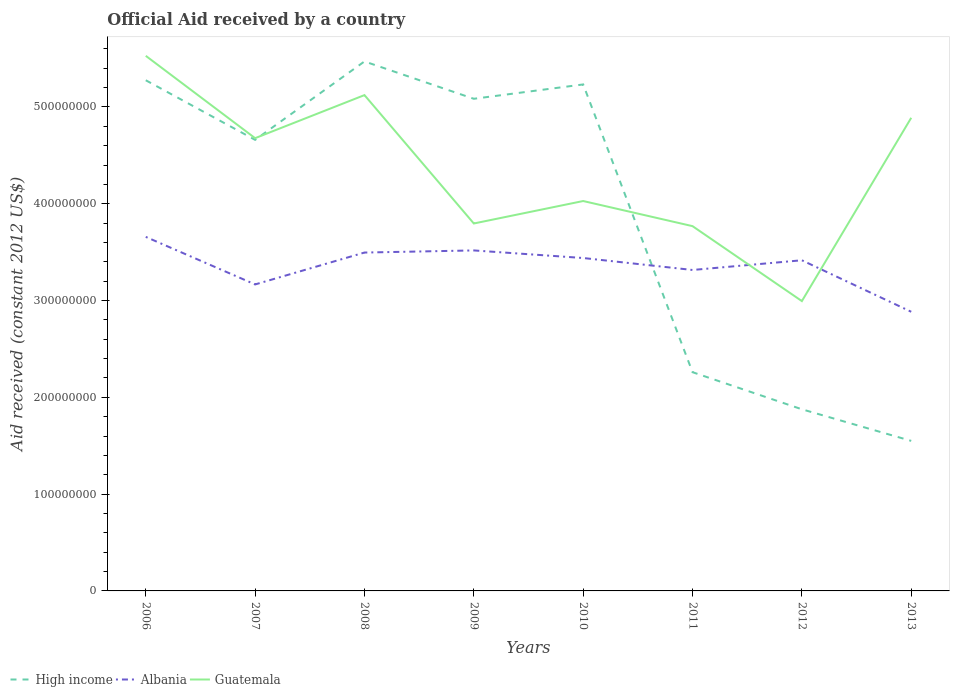How many different coloured lines are there?
Provide a short and direct response. 3. Does the line corresponding to Guatemala intersect with the line corresponding to High income?
Offer a terse response. Yes. Is the number of lines equal to the number of legend labels?
Keep it short and to the point. Yes. Across all years, what is the maximum net official aid received in Albania?
Your answer should be compact. 2.88e+08. In which year was the net official aid received in Albania maximum?
Give a very brief answer. 2013. What is the total net official aid received in High income in the graph?
Keep it short and to the point. 3.02e+08. What is the difference between the highest and the second highest net official aid received in Guatemala?
Provide a succinct answer. 2.53e+08. What is the difference between the highest and the lowest net official aid received in High income?
Your answer should be very brief. 5. How many lines are there?
Keep it short and to the point. 3. How many years are there in the graph?
Offer a very short reply. 8. Does the graph contain any zero values?
Your answer should be very brief. No. Does the graph contain grids?
Give a very brief answer. No. Where does the legend appear in the graph?
Ensure brevity in your answer.  Bottom left. How many legend labels are there?
Offer a very short reply. 3. How are the legend labels stacked?
Your response must be concise. Horizontal. What is the title of the graph?
Your response must be concise. Official Aid received by a country. What is the label or title of the Y-axis?
Offer a very short reply. Aid received (constant 2012 US$). What is the Aid received (constant 2012 US$) in High income in 2006?
Your response must be concise. 5.28e+08. What is the Aid received (constant 2012 US$) of Albania in 2006?
Your answer should be very brief. 3.66e+08. What is the Aid received (constant 2012 US$) of Guatemala in 2006?
Offer a terse response. 5.53e+08. What is the Aid received (constant 2012 US$) in High income in 2007?
Ensure brevity in your answer.  4.66e+08. What is the Aid received (constant 2012 US$) of Albania in 2007?
Give a very brief answer. 3.17e+08. What is the Aid received (constant 2012 US$) of Guatemala in 2007?
Your answer should be very brief. 4.68e+08. What is the Aid received (constant 2012 US$) of High income in 2008?
Provide a succinct answer. 5.47e+08. What is the Aid received (constant 2012 US$) of Albania in 2008?
Provide a short and direct response. 3.50e+08. What is the Aid received (constant 2012 US$) of Guatemala in 2008?
Offer a very short reply. 5.12e+08. What is the Aid received (constant 2012 US$) of High income in 2009?
Offer a very short reply. 5.08e+08. What is the Aid received (constant 2012 US$) in Albania in 2009?
Make the answer very short. 3.52e+08. What is the Aid received (constant 2012 US$) of Guatemala in 2009?
Offer a very short reply. 3.80e+08. What is the Aid received (constant 2012 US$) of High income in 2010?
Ensure brevity in your answer.  5.23e+08. What is the Aid received (constant 2012 US$) of Albania in 2010?
Provide a short and direct response. 3.44e+08. What is the Aid received (constant 2012 US$) in Guatemala in 2010?
Offer a terse response. 4.03e+08. What is the Aid received (constant 2012 US$) in High income in 2011?
Keep it short and to the point. 2.26e+08. What is the Aid received (constant 2012 US$) of Albania in 2011?
Offer a terse response. 3.32e+08. What is the Aid received (constant 2012 US$) in Guatemala in 2011?
Make the answer very short. 3.77e+08. What is the Aid received (constant 2012 US$) of High income in 2012?
Provide a short and direct response. 1.88e+08. What is the Aid received (constant 2012 US$) in Albania in 2012?
Your response must be concise. 3.42e+08. What is the Aid received (constant 2012 US$) of Guatemala in 2012?
Your answer should be compact. 2.99e+08. What is the Aid received (constant 2012 US$) of High income in 2013?
Your answer should be compact. 1.55e+08. What is the Aid received (constant 2012 US$) of Albania in 2013?
Your answer should be very brief. 2.88e+08. What is the Aid received (constant 2012 US$) in Guatemala in 2013?
Provide a short and direct response. 4.89e+08. Across all years, what is the maximum Aid received (constant 2012 US$) in High income?
Keep it short and to the point. 5.47e+08. Across all years, what is the maximum Aid received (constant 2012 US$) of Albania?
Provide a succinct answer. 3.66e+08. Across all years, what is the maximum Aid received (constant 2012 US$) of Guatemala?
Make the answer very short. 5.53e+08. Across all years, what is the minimum Aid received (constant 2012 US$) in High income?
Keep it short and to the point. 1.55e+08. Across all years, what is the minimum Aid received (constant 2012 US$) in Albania?
Your answer should be very brief. 2.88e+08. Across all years, what is the minimum Aid received (constant 2012 US$) in Guatemala?
Your response must be concise. 2.99e+08. What is the total Aid received (constant 2012 US$) in High income in the graph?
Offer a terse response. 3.14e+09. What is the total Aid received (constant 2012 US$) of Albania in the graph?
Provide a short and direct response. 2.69e+09. What is the total Aid received (constant 2012 US$) in Guatemala in the graph?
Your answer should be compact. 3.48e+09. What is the difference between the Aid received (constant 2012 US$) of High income in 2006 and that in 2007?
Your answer should be very brief. 6.16e+07. What is the difference between the Aid received (constant 2012 US$) of Albania in 2006 and that in 2007?
Provide a succinct answer. 4.91e+07. What is the difference between the Aid received (constant 2012 US$) of Guatemala in 2006 and that in 2007?
Provide a succinct answer. 8.51e+07. What is the difference between the Aid received (constant 2012 US$) in High income in 2006 and that in 2008?
Offer a very short reply. -1.94e+07. What is the difference between the Aid received (constant 2012 US$) in Albania in 2006 and that in 2008?
Give a very brief answer. 1.62e+07. What is the difference between the Aid received (constant 2012 US$) in Guatemala in 2006 and that in 2008?
Offer a very short reply. 4.06e+07. What is the difference between the Aid received (constant 2012 US$) in High income in 2006 and that in 2009?
Give a very brief answer. 1.91e+07. What is the difference between the Aid received (constant 2012 US$) of Albania in 2006 and that in 2009?
Provide a short and direct response. 1.40e+07. What is the difference between the Aid received (constant 2012 US$) of Guatemala in 2006 and that in 2009?
Offer a terse response. 1.73e+08. What is the difference between the Aid received (constant 2012 US$) in High income in 2006 and that in 2010?
Give a very brief answer. 4.32e+06. What is the difference between the Aid received (constant 2012 US$) in Albania in 2006 and that in 2010?
Your response must be concise. 2.18e+07. What is the difference between the Aid received (constant 2012 US$) of Guatemala in 2006 and that in 2010?
Your response must be concise. 1.50e+08. What is the difference between the Aid received (constant 2012 US$) of High income in 2006 and that in 2011?
Provide a short and direct response. 3.02e+08. What is the difference between the Aid received (constant 2012 US$) of Albania in 2006 and that in 2011?
Provide a succinct answer. 3.42e+07. What is the difference between the Aid received (constant 2012 US$) in Guatemala in 2006 and that in 2011?
Ensure brevity in your answer.  1.76e+08. What is the difference between the Aid received (constant 2012 US$) of High income in 2006 and that in 2012?
Ensure brevity in your answer.  3.40e+08. What is the difference between the Aid received (constant 2012 US$) in Albania in 2006 and that in 2012?
Make the answer very short. 2.42e+07. What is the difference between the Aid received (constant 2012 US$) of Guatemala in 2006 and that in 2012?
Provide a short and direct response. 2.53e+08. What is the difference between the Aid received (constant 2012 US$) of High income in 2006 and that in 2013?
Offer a terse response. 3.73e+08. What is the difference between the Aid received (constant 2012 US$) in Albania in 2006 and that in 2013?
Ensure brevity in your answer.  7.74e+07. What is the difference between the Aid received (constant 2012 US$) of Guatemala in 2006 and that in 2013?
Offer a terse response. 6.40e+07. What is the difference between the Aid received (constant 2012 US$) of High income in 2007 and that in 2008?
Offer a terse response. -8.10e+07. What is the difference between the Aid received (constant 2012 US$) of Albania in 2007 and that in 2008?
Give a very brief answer. -3.29e+07. What is the difference between the Aid received (constant 2012 US$) of Guatemala in 2007 and that in 2008?
Provide a short and direct response. -4.45e+07. What is the difference between the Aid received (constant 2012 US$) in High income in 2007 and that in 2009?
Offer a terse response. -4.24e+07. What is the difference between the Aid received (constant 2012 US$) of Albania in 2007 and that in 2009?
Ensure brevity in your answer.  -3.51e+07. What is the difference between the Aid received (constant 2012 US$) in Guatemala in 2007 and that in 2009?
Offer a terse response. 8.82e+07. What is the difference between the Aid received (constant 2012 US$) in High income in 2007 and that in 2010?
Your answer should be very brief. -5.73e+07. What is the difference between the Aid received (constant 2012 US$) in Albania in 2007 and that in 2010?
Provide a short and direct response. -2.73e+07. What is the difference between the Aid received (constant 2012 US$) of Guatemala in 2007 and that in 2010?
Provide a short and direct response. 6.49e+07. What is the difference between the Aid received (constant 2012 US$) of High income in 2007 and that in 2011?
Keep it short and to the point. 2.40e+08. What is the difference between the Aid received (constant 2012 US$) in Albania in 2007 and that in 2011?
Make the answer very short. -1.49e+07. What is the difference between the Aid received (constant 2012 US$) in Guatemala in 2007 and that in 2011?
Keep it short and to the point. 9.09e+07. What is the difference between the Aid received (constant 2012 US$) of High income in 2007 and that in 2012?
Your response must be concise. 2.78e+08. What is the difference between the Aid received (constant 2012 US$) of Albania in 2007 and that in 2012?
Give a very brief answer. -2.50e+07. What is the difference between the Aid received (constant 2012 US$) of Guatemala in 2007 and that in 2012?
Your answer should be very brief. 1.68e+08. What is the difference between the Aid received (constant 2012 US$) in High income in 2007 and that in 2013?
Ensure brevity in your answer.  3.11e+08. What is the difference between the Aid received (constant 2012 US$) in Albania in 2007 and that in 2013?
Make the answer very short. 2.82e+07. What is the difference between the Aid received (constant 2012 US$) in Guatemala in 2007 and that in 2013?
Your response must be concise. -2.10e+07. What is the difference between the Aid received (constant 2012 US$) of High income in 2008 and that in 2009?
Your response must be concise. 3.86e+07. What is the difference between the Aid received (constant 2012 US$) of Albania in 2008 and that in 2009?
Offer a terse response. -2.20e+06. What is the difference between the Aid received (constant 2012 US$) of Guatemala in 2008 and that in 2009?
Provide a short and direct response. 1.33e+08. What is the difference between the Aid received (constant 2012 US$) of High income in 2008 and that in 2010?
Provide a succinct answer. 2.38e+07. What is the difference between the Aid received (constant 2012 US$) in Albania in 2008 and that in 2010?
Provide a succinct answer. 5.64e+06. What is the difference between the Aid received (constant 2012 US$) in Guatemala in 2008 and that in 2010?
Ensure brevity in your answer.  1.09e+08. What is the difference between the Aid received (constant 2012 US$) in High income in 2008 and that in 2011?
Offer a terse response. 3.21e+08. What is the difference between the Aid received (constant 2012 US$) of Albania in 2008 and that in 2011?
Your answer should be very brief. 1.80e+07. What is the difference between the Aid received (constant 2012 US$) in Guatemala in 2008 and that in 2011?
Provide a succinct answer. 1.35e+08. What is the difference between the Aid received (constant 2012 US$) in High income in 2008 and that in 2012?
Offer a terse response. 3.59e+08. What is the difference between the Aid received (constant 2012 US$) of Albania in 2008 and that in 2012?
Your answer should be very brief. 7.97e+06. What is the difference between the Aid received (constant 2012 US$) in Guatemala in 2008 and that in 2012?
Offer a terse response. 2.13e+08. What is the difference between the Aid received (constant 2012 US$) of High income in 2008 and that in 2013?
Your answer should be compact. 3.92e+08. What is the difference between the Aid received (constant 2012 US$) of Albania in 2008 and that in 2013?
Provide a short and direct response. 6.12e+07. What is the difference between the Aid received (constant 2012 US$) in Guatemala in 2008 and that in 2013?
Make the answer very short. 2.34e+07. What is the difference between the Aid received (constant 2012 US$) of High income in 2009 and that in 2010?
Your response must be concise. -1.48e+07. What is the difference between the Aid received (constant 2012 US$) in Albania in 2009 and that in 2010?
Your answer should be very brief. 7.84e+06. What is the difference between the Aid received (constant 2012 US$) of Guatemala in 2009 and that in 2010?
Give a very brief answer. -2.32e+07. What is the difference between the Aid received (constant 2012 US$) of High income in 2009 and that in 2011?
Make the answer very short. 2.82e+08. What is the difference between the Aid received (constant 2012 US$) in Albania in 2009 and that in 2011?
Give a very brief answer. 2.02e+07. What is the difference between the Aid received (constant 2012 US$) in Guatemala in 2009 and that in 2011?
Keep it short and to the point. 2.74e+06. What is the difference between the Aid received (constant 2012 US$) in High income in 2009 and that in 2012?
Provide a short and direct response. 3.21e+08. What is the difference between the Aid received (constant 2012 US$) in Albania in 2009 and that in 2012?
Your answer should be compact. 1.02e+07. What is the difference between the Aid received (constant 2012 US$) of Guatemala in 2009 and that in 2012?
Keep it short and to the point. 8.02e+07. What is the difference between the Aid received (constant 2012 US$) of High income in 2009 and that in 2013?
Give a very brief answer. 3.53e+08. What is the difference between the Aid received (constant 2012 US$) in Albania in 2009 and that in 2013?
Your response must be concise. 6.34e+07. What is the difference between the Aid received (constant 2012 US$) of Guatemala in 2009 and that in 2013?
Your response must be concise. -1.09e+08. What is the difference between the Aid received (constant 2012 US$) of High income in 2010 and that in 2011?
Provide a succinct answer. 2.97e+08. What is the difference between the Aid received (constant 2012 US$) in Albania in 2010 and that in 2011?
Your answer should be compact. 1.24e+07. What is the difference between the Aid received (constant 2012 US$) of Guatemala in 2010 and that in 2011?
Give a very brief answer. 2.60e+07. What is the difference between the Aid received (constant 2012 US$) of High income in 2010 and that in 2012?
Keep it short and to the point. 3.36e+08. What is the difference between the Aid received (constant 2012 US$) in Albania in 2010 and that in 2012?
Provide a succinct answer. 2.33e+06. What is the difference between the Aid received (constant 2012 US$) of Guatemala in 2010 and that in 2012?
Ensure brevity in your answer.  1.03e+08. What is the difference between the Aid received (constant 2012 US$) of High income in 2010 and that in 2013?
Keep it short and to the point. 3.68e+08. What is the difference between the Aid received (constant 2012 US$) in Albania in 2010 and that in 2013?
Ensure brevity in your answer.  5.56e+07. What is the difference between the Aid received (constant 2012 US$) of Guatemala in 2010 and that in 2013?
Ensure brevity in your answer.  -8.60e+07. What is the difference between the Aid received (constant 2012 US$) in High income in 2011 and that in 2012?
Provide a short and direct response. 3.83e+07. What is the difference between the Aid received (constant 2012 US$) of Albania in 2011 and that in 2012?
Your answer should be very brief. -1.00e+07. What is the difference between the Aid received (constant 2012 US$) of Guatemala in 2011 and that in 2012?
Offer a terse response. 7.74e+07. What is the difference between the Aid received (constant 2012 US$) in High income in 2011 and that in 2013?
Give a very brief answer. 7.10e+07. What is the difference between the Aid received (constant 2012 US$) in Albania in 2011 and that in 2013?
Your response must be concise. 4.32e+07. What is the difference between the Aid received (constant 2012 US$) of Guatemala in 2011 and that in 2013?
Provide a short and direct response. -1.12e+08. What is the difference between the Aid received (constant 2012 US$) in High income in 2012 and that in 2013?
Give a very brief answer. 3.26e+07. What is the difference between the Aid received (constant 2012 US$) in Albania in 2012 and that in 2013?
Keep it short and to the point. 5.32e+07. What is the difference between the Aid received (constant 2012 US$) of Guatemala in 2012 and that in 2013?
Your answer should be very brief. -1.89e+08. What is the difference between the Aid received (constant 2012 US$) in High income in 2006 and the Aid received (constant 2012 US$) in Albania in 2007?
Provide a short and direct response. 2.11e+08. What is the difference between the Aid received (constant 2012 US$) in High income in 2006 and the Aid received (constant 2012 US$) in Guatemala in 2007?
Your answer should be compact. 5.98e+07. What is the difference between the Aid received (constant 2012 US$) of Albania in 2006 and the Aid received (constant 2012 US$) of Guatemala in 2007?
Make the answer very short. -1.02e+08. What is the difference between the Aid received (constant 2012 US$) in High income in 2006 and the Aid received (constant 2012 US$) in Albania in 2008?
Your answer should be very brief. 1.78e+08. What is the difference between the Aid received (constant 2012 US$) of High income in 2006 and the Aid received (constant 2012 US$) of Guatemala in 2008?
Your answer should be very brief. 1.53e+07. What is the difference between the Aid received (constant 2012 US$) in Albania in 2006 and the Aid received (constant 2012 US$) in Guatemala in 2008?
Your response must be concise. -1.46e+08. What is the difference between the Aid received (constant 2012 US$) in High income in 2006 and the Aid received (constant 2012 US$) in Albania in 2009?
Ensure brevity in your answer.  1.76e+08. What is the difference between the Aid received (constant 2012 US$) in High income in 2006 and the Aid received (constant 2012 US$) in Guatemala in 2009?
Offer a very short reply. 1.48e+08. What is the difference between the Aid received (constant 2012 US$) of Albania in 2006 and the Aid received (constant 2012 US$) of Guatemala in 2009?
Your answer should be compact. -1.38e+07. What is the difference between the Aid received (constant 2012 US$) of High income in 2006 and the Aid received (constant 2012 US$) of Albania in 2010?
Keep it short and to the point. 1.84e+08. What is the difference between the Aid received (constant 2012 US$) in High income in 2006 and the Aid received (constant 2012 US$) in Guatemala in 2010?
Provide a succinct answer. 1.25e+08. What is the difference between the Aid received (constant 2012 US$) of Albania in 2006 and the Aid received (constant 2012 US$) of Guatemala in 2010?
Provide a succinct answer. -3.70e+07. What is the difference between the Aid received (constant 2012 US$) in High income in 2006 and the Aid received (constant 2012 US$) in Albania in 2011?
Give a very brief answer. 1.96e+08. What is the difference between the Aid received (constant 2012 US$) in High income in 2006 and the Aid received (constant 2012 US$) in Guatemala in 2011?
Keep it short and to the point. 1.51e+08. What is the difference between the Aid received (constant 2012 US$) of Albania in 2006 and the Aid received (constant 2012 US$) of Guatemala in 2011?
Offer a terse response. -1.11e+07. What is the difference between the Aid received (constant 2012 US$) of High income in 2006 and the Aid received (constant 2012 US$) of Albania in 2012?
Your answer should be very brief. 1.86e+08. What is the difference between the Aid received (constant 2012 US$) of High income in 2006 and the Aid received (constant 2012 US$) of Guatemala in 2012?
Offer a terse response. 2.28e+08. What is the difference between the Aid received (constant 2012 US$) of Albania in 2006 and the Aid received (constant 2012 US$) of Guatemala in 2012?
Your answer should be very brief. 6.63e+07. What is the difference between the Aid received (constant 2012 US$) in High income in 2006 and the Aid received (constant 2012 US$) in Albania in 2013?
Provide a succinct answer. 2.39e+08. What is the difference between the Aid received (constant 2012 US$) in High income in 2006 and the Aid received (constant 2012 US$) in Guatemala in 2013?
Provide a short and direct response. 3.88e+07. What is the difference between the Aid received (constant 2012 US$) of Albania in 2006 and the Aid received (constant 2012 US$) of Guatemala in 2013?
Give a very brief answer. -1.23e+08. What is the difference between the Aid received (constant 2012 US$) in High income in 2007 and the Aid received (constant 2012 US$) in Albania in 2008?
Offer a very short reply. 1.16e+08. What is the difference between the Aid received (constant 2012 US$) in High income in 2007 and the Aid received (constant 2012 US$) in Guatemala in 2008?
Provide a succinct answer. -4.62e+07. What is the difference between the Aid received (constant 2012 US$) in Albania in 2007 and the Aid received (constant 2012 US$) in Guatemala in 2008?
Provide a short and direct response. -1.96e+08. What is the difference between the Aid received (constant 2012 US$) of High income in 2007 and the Aid received (constant 2012 US$) of Albania in 2009?
Make the answer very short. 1.14e+08. What is the difference between the Aid received (constant 2012 US$) in High income in 2007 and the Aid received (constant 2012 US$) in Guatemala in 2009?
Offer a terse response. 8.64e+07. What is the difference between the Aid received (constant 2012 US$) in Albania in 2007 and the Aid received (constant 2012 US$) in Guatemala in 2009?
Your answer should be very brief. -6.30e+07. What is the difference between the Aid received (constant 2012 US$) of High income in 2007 and the Aid received (constant 2012 US$) of Albania in 2010?
Ensure brevity in your answer.  1.22e+08. What is the difference between the Aid received (constant 2012 US$) of High income in 2007 and the Aid received (constant 2012 US$) of Guatemala in 2010?
Offer a very short reply. 6.32e+07. What is the difference between the Aid received (constant 2012 US$) in Albania in 2007 and the Aid received (constant 2012 US$) in Guatemala in 2010?
Your answer should be compact. -8.62e+07. What is the difference between the Aid received (constant 2012 US$) in High income in 2007 and the Aid received (constant 2012 US$) in Albania in 2011?
Your response must be concise. 1.34e+08. What is the difference between the Aid received (constant 2012 US$) in High income in 2007 and the Aid received (constant 2012 US$) in Guatemala in 2011?
Your answer should be very brief. 8.91e+07. What is the difference between the Aid received (constant 2012 US$) of Albania in 2007 and the Aid received (constant 2012 US$) of Guatemala in 2011?
Provide a short and direct response. -6.02e+07. What is the difference between the Aid received (constant 2012 US$) in High income in 2007 and the Aid received (constant 2012 US$) in Albania in 2012?
Provide a succinct answer. 1.24e+08. What is the difference between the Aid received (constant 2012 US$) of High income in 2007 and the Aid received (constant 2012 US$) of Guatemala in 2012?
Give a very brief answer. 1.67e+08. What is the difference between the Aid received (constant 2012 US$) of Albania in 2007 and the Aid received (constant 2012 US$) of Guatemala in 2012?
Provide a short and direct response. 1.72e+07. What is the difference between the Aid received (constant 2012 US$) in High income in 2007 and the Aid received (constant 2012 US$) in Albania in 2013?
Offer a terse response. 1.78e+08. What is the difference between the Aid received (constant 2012 US$) of High income in 2007 and the Aid received (constant 2012 US$) of Guatemala in 2013?
Provide a succinct answer. -2.28e+07. What is the difference between the Aid received (constant 2012 US$) in Albania in 2007 and the Aid received (constant 2012 US$) in Guatemala in 2013?
Your answer should be compact. -1.72e+08. What is the difference between the Aid received (constant 2012 US$) in High income in 2008 and the Aid received (constant 2012 US$) in Albania in 2009?
Give a very brief answer. 1.95e+08. What is the difference between the Aid received (constant 2012 US$) in High income in 2008 and the Aid received (constant 2012 US$) in Guatemala in 2009?
Provide a short and direct response. 1.67e+08. What is the difference between the Aid received (constant 2012 US$) in Albania in 2008 and the Aid received (constant 2012 US$) in Guatemala in 2009?
Make the answer very short. -3.00e+07. What is the difference between the Aid received (constant 2012 US$) of High income in 2008 and the Aid received (constant 2012 US$) of Albania in 2010?
Provide a succinct answer. 2.03e+08. What is the difference between the Aid received (constant 2012 US$) of High income in 2008 and the Aid received (constant 2012 US$) of Guatemala in 2010?
Provide a short and direct response. 1.44e+08. What is the difference between the Aid received (constant 2012 US$) in Albania in 2008 and the Aid received (constant 2012 US$) in Guatemala in 2010?
Provide a succinct answer. -5.32e+07. What is the difference between the Aid received (constant 2012 US$) in High income in 2008 and the Aid received (constant 2012 US$) in Albania in 2011?
Give a very brief answer. 2.15e+08. What is the difference between the Aid received (constant 2012 US$) of High income in 2008 and the Aid received (constant 2012 US$) of Guatemala in 2011?
Provide a succinct answer. 1.70e+08. What is the difference between the Aid received (constant 2012 US$) in Albania in 2008 and the Aid received (constant 2012 US$) in Guatemala in 2011?
Make the answer very short. -2.73e+07. What is the difference between the Aid received (constant 2012 US$) in High income in 2008 and the Aid received (constant 2012 US$) in Albania in 2012?
Offer a terse response. 2.05e+08. What is the difference between the Aid received (constant 2012 US$) of High income in 2008 and the Aid received (constant 2012 US$) of Guatemala in 2012?
Keep it short and to the point. 2.48e+08. What is the difference between the Aid received (constant 2012 US$) in Albania in 2008 and the Aid received (constant 2012 US$) in Guatemala in 2012?
Make the answer very short. 5.02e+07. What is the difference between the Aid received (constant 2012 US$) of High income in 2008 and the Aid received (constant 2012 US$) of Albania in 2013?
Make the answer very short. 2.59e+08. What is the difference between the Aid received (constant 2012 US$) in High income in 2008 and the Aid received (constant 2012 US$) in Guatemala in 2013?
Offer a very short reply. 5.82e+07. What is the difference between the Aid received (constant 2012 US$) in Albania in 2008 and the Aid received (constant 2012 US$) in Guatemala in 2013?
Keep it short and to the point. -1.39e+08. What is the difference between the Aid received (constant 2012 US$) of High income in 2009 and the Aid received (constant 2012 US$) of Albania in 2010?
Provide a short and direct response. 1.65e+08. What is the difference between the Aid received (constant 2012 US$) of High income in 2009 and the Aid received (constant 2012 US$) of Guatemala in 2010?
Ensure brevity in your answer.  1.06e+08. What is the difference between the Aid received (constant 2012 US$) in Albania in 2009 and the Aid received (constant 2012 US$) in Guatemala in 2010?
Give a very brief answer. -5.10e+07. What is the difference between the Aid received (constant 2012 US$) of High income in 2009 and the Aid received (constant 2012 US$) of Albania in 2011?
Make the answer very short. 1.77e+08. What is the difference between the Aid received (constant 2012 US$) in High income in 2009 and the Aid received (constant 2012 US$) in Guatemala in 2011?
Ensure brevity in your answer.  1.32e+08. What is the difference between the Aid received (constant 2012 US$) of Albania in 2009 and the Aid received (constant 2012 US$) of Guatemala in 2011?
Keep it short and to the point. -2.51e+07. What is the difference between the Aid received (constant 2012 US$) in High income in 2009 and the Aid received (constant 2012 US$) in Albania in 2012?
Provide a short and direct response. 1.67e+08. What is the difference between the Aid received (constant 2012 US$) in High income in 2009 and the Aid received (constant 2012 US$) in Guatemala in 2012?
Offer a very short reply. 2.09e+08. What is the difference between the Aid received (constant 2012 US$) of Albania in 2009 and the Aid received (constant 2012 US$) of Guatemala in 2012?
Provide a succinct answer. 5.24e+07. What is the difference between the Aid received (constant 2012 US$) in High income in 2009 and the Aid received (constant 2012 US$) in Albania in 2013?
Provide a succinct answer. 2.20e+08. What is the difference between the Aid received (constant 2012 US$) of High income in 2009 and the Aid received (constant 2012 US$) of Guatemala in 2013?
Make the answer very short. 1.96e+07. What is the difference between the Aid received (constant 2012 US$) in Albania in 2009 and the Aid received (constant 2012 US$) in Guatemala in 2013?
Offer a very short reply. -1.37e+08. What is the difference between the Aid received (constant 2012 US$) in High income in 2010 and the Aid received (constant 2012 US$) in Albania in 2011?
Keep it short and to the point. 1.92e+08. What is the difference between the Aid received (constant 2012 US$) in High income in 2010 and the Aid received (constant 2012 US$) in Guatemala in 2011?
Provide a short and direct response. 1.46e+08. What is the difference between the Aid received (constant 2012 US$) of Albania in 2010 and the Aid received (constant 2012 US$) of Guatemala in 2011?
Offer a very short reply. -3.29e+07. What is the difference between the Aid received (constant 2012 US$) of High income in 2010 and the Aid received (constant 2012 US$) of Albania in 2012?
Offer a terse response. 1.82e+08. What is the difference between the Aid received (constant 2012 US$) in High income in 2010 and the Aid received (constant 2012 US$) in Guatemala in 2012?
Offer a very short reply. 2.24e+08. What is the difference between the Aid received (constant 2012 US$) of Albania in 2010 and the Aid received (constant 2012 US$) of Guatemala in 2012?
Give a very brief answer. 4.45e+07. What is the difference between the Aid received (constant 2012 US$) in High income in 2010 and the Aid received (constant 2012 US$) in Albania in 2013?
Keep it short and to the point. 2.35e+08. What is the difference between the Aid received (constant 2012 US$) of High income in 2010 and the Aid received (constant 2012 US$) of Guatemala in 2013?
Provide a short and direct response. 3.45e+07. What is the difference between the Aid received (constant 2012 US$) of Albania in 2010 and the Aid received (constant 2012 US$) of Guatemala in 2013?
Ensure brevity in your answer.  -1.45e+08. What is the difference between the Aid received (constant 2012 US$) in High income in 2011 and the Aid received (constant 2012 US$) in Albania in 2012?
Your answer should be compact. -1.16e+08. What is the difference between the Aid received (constant 2012 US$) in High income in 2011 and the Aid received (constant 2012 US$) in Guatemala in 2012?
Ensure brevity in your answer.  -7.34e+07. What is the difference between the Aid received (constant 2012 US$) of Albania in 2011 and the Aid received (constant 2012 US$) of Guatemala in 2012?
Make the answer very short. 3.22e+07. What is the difference between the Aid received (constant 2012 US$) of High income in 2011 and the Aid received (constant 2012 US$) of Albania in 2013?
Provide a succinct answer. -6.24e+07. What is the difference between the Aid received (constant 2012 US$) of High income in 2011 and the Aid received (constant 2012 US$) of Guatemala in 2013?
Make the answer very short. -2.63e+08. What is the difference between the Aid received (constant 2012 US$) in Albania in 2011 and the Aid received (constant 2012 US$) in Guatemala in 2013?
Your response must be concise. -1.57e+08. What is the difference between the Aid received (constant 2012 US$) in High income in 2012 and the Aid received (constant 2012 US$) in Albania in 2013?
Your answer should be very brief. -1.01e+08. What is the difference between the Aid received (constant 2012 US$) in High income in 2012 and the Aid received (constant 2012 US$) in Guatemala in 2013?
Give a very brief answer. -3.01e+08. What is the difference between the Aid received (constant 2012 US$) in Albania in 2012 and the Aid received (constant 2012 US$) in Guatemala in 2013?
Provide a succinct answer. -1.47e+08. What is the average Aid received (constant 2012 US$) of High income per year?
Your answer should be compact. 3.93e+08. What is the average Aid received (constant 2012 US$) in Albania per year?
Keep it short and to the point. 3.36e+08. What is the average Aid received (constant 2012 US$) of Guatemala per year?
Your answer should be compact. 4.35e+08. In the year 2006, what is the difference between the Aid received (constant 2012 US$) in High income and Aid received (constant 2012 US$) in Albania?
Your answer should be compact. 1.62e+08. In the year 2006, what is the difference between the Aid received (constant 2012 US$) in High income and Aid received (constant 2012 US$) in Guatemala?
Give a very brief answer. -2.52e+07. In the year 2006, what is the difference between the Aid received (constant 2012 US$) in Albania and Aid received (constant 2012 US$) in Guatemala?
Your answer should be compact. -1.87e+08. In the year 2007, what is the difference between the Aid received (constant 2012 US$) in High income and Aid received (constant 2012 US$) in Albania?
Ensure brevity in your answer.  1.49e+08. In the year 2007, what is the difference between the Aid received (constant 2012 US$) in High income and Aid received (constant 2012 US$) in Guatemala?
Your response must be concise. -1.75e+06. In the year 2007, what is the difference between the Aid received (constant 2012 US$) in Albania and Aid received (constant 2012 US$) in Guatemala?
Offer a terse response. -1.51e+08. In the year 2008, what is the difference between the Aid received (constant 2012 US$) in High income and Aid received (constant 2012 US$) in Albania?
Offer a very short reply. 1.97e+08. In the year 2008, what is the difference between the Aid received (constant 2012 US$) of High income and Aid received (constant 2012 US$) of Guatemala?
Your response must be concise. 3.48e+07. In the year 2008, what is the difference between the Aid received (constant 2012 US$) of Albania and Aid received (constant 2012 US$) of Guatemala?
Give a very brief answer. -1.63e+08. In the year 2009, what is the difference between the Aid received (constant 2012 US$) of High income and Aid received (constant 2012 US$) of Albania?
Your answer should be compact. 1.57e+08. In the year 2009, what is the difference between the Aid received (constant 2012 US$) of High income and Aid received (constant 2012 US$) of Guatemala?
Provide a succinct answer. 1.29e+08. In the year 2009, what is the difference between the Aid received (constant 2012 US$) in Albania and Aid received (constant 2012 US$) in Guatemala?
Provide a succinct answer. -2.78e+07. In the year 2010, what is the difference between the Aid received (constant 2012 US$) of High income and Aid received (constant 2012 US$) of Albania?
Offer a terse response. 1.79e+08. In the year 2010, what is the difference between the Aid received (constant 2012 US$) in High income and Aid received (constant 2012 US$) in Guatemala?
Your response must be concise. 1.20e+08. In the year 2010, what is the difference between the Aid received (constant 2012 US$) of Albania and Aid received (constant 2012 US$) of Guatemala?
Keep it short and to the point. -5.89e+07. In the year 2011, what is the difference between the Aid received (constant 2012 US$) in High income and Aid received (constant 2012 US$) in Albania?
Your answer should be very brief. -1.06e+08. In the year 2011, what is the difference between the Aid received (constant 2012 US$) in High income and Aid received (constant 2012 US$) in Guatemala?
Keep it short and to the point. -1.51e+08. In the year 2011, what is the difference between the Aid received (constant 2012 US$) in Albania and Aid received (constant 2012 US$) in Guatemala?
Offer a terse response. -4.53e+07. In the year 2012, what is the difference between the Aid received (constant 2012 US$) in High income and Aid received (constant 2012 US$) in Albania?
Offer a very short reply. -1.54e+08. In the year 2012, what is the difference between the Aid received (constant 2012 US$) of High income and Aid received (constant 2012 US$) of Guatemala?
Provide a succinct answer. -1.12e+08. In the year 2012, what is the difference between the Aid received (constant 2012 US$) in Albania and Aid received (constant 2012 US$) in Guatemala?
Your answer should be very brief. 4.22e+07. In the year 2013, what is the difference between the Aid received (constant 2012 US$) in High income and Aid received (constant 2012 US$) in Albania?
Offer a very short reply. -1.33e+08. In the year 2013, what is the difference between the Aid received (constant 2012 US$) in High income and Aid received (constant 2012 US$) in Guatemala?
Offer a very short reply. -3.34e+08. In the year 2013, what is the difference between the Aid received (constant 2012 US$) of Albania and Aid received (constant 2012 US$) of Guatemala?
Your answer should be very brief. -2.00e+08. What is the ratio of the Aid received (constant 2012 US$) of High income in 2006 to that in 2007?
Your answer should be very brief. 1.13. What is the ratio of the Aid received (constant 2012 US$) in Albania in 2006 to that in 2007?
Provide a short and direct response. 1.16. What is the ratio of the Aid received (constant 2012 US$) of Guatemala in 2006 to that in 2007?
Provide a short and direct response. 1.18. What is the ratio of the Aid received (constant 2012 US$) in High income in 2006 to that in 2008?
Provide a short and direct response. 0.96. What is the ratio of the Aid received (constant 2012 US$) in Albania in 2006 to that in 2008?
Provide a short and direct response. 1.05. What is the ratio of the Aid received (constant 2012 US$) in Guatemala in 2006 to that in 2008?
Ensure brevity in your answer.  1.08. What is the ratio of the Aid received (constant 2012 US$) of High income in 2006 to that in 2009?
Offer a very short reply. 1.04. What is the ratio of the Aid received (constant 2012 US$) in Albania in 2006 to that in 2009?
Your answer should be very brief. 1.04. What is the ratio of the Aid received (constant 2012 US$) in Guatemala in 2006 to that in 2009?
Provide a short and direct response. 1.46. What is the ratio of the Aid received (constant 2012 US$) in High income in 2006 to that in 2010?
Provide a short and direct response. 1.01. What is the ratio of the Aid received (constant 2012 US$) in Albania in 2006 to that in 2010?
Offer a very short reply. 1.06. What is the ratio of the Aid received (constant 2012 US$) of Guatemala in 2006 to that in 2010?
Your answer should be compact. 1.37. What is the ratio of the Aid received (constant 2012 US$) of High income in 2006 to that in 2011?
Ensure brevity in your answer.  2.33. What is the ratio of the Aid received (constant 2012 US$) in Albania in 2006 to that in 2011?
Keep it short and to the point. 1.1. What is the ratio of the Aid received (constant 2012 US$) of Guatemala in 2006 to that in 2011?
Make the answer very short. 1.47. What is the ratio of the Aid received (constant 2012 US$) of High income in 2006 to that in 2012?
Offer a very short reply. 2.81. What is the ratio of the Aid received (constant 2012 US$) of Albania in 2006 to that in 2012?
Offer a very short reply. 1.07. What is the ratio of the Aid received (constant 2012 US$) of Guatemala in 2006 to that in 2012?
Your answer should be compact. 1.85. What is the ratio of the Aid received (constant 2012 US$) of High income in 2006 to that in 2013?
Keep it short and to the point. 3.4. What is the ratio of the Aid received (constant 2012 US$) of Albania in 2006 to that in 2013?
Offer a terse response. 1.27. What is the ratio of the Aid received (constant 2012 US$) of Guatemala in 2006 to that in 2013?
Your answer should be compact. 1.13. What is the ratio of the Aid received (constant 2012 US$) of High income in 2007 to that in 2008?
Your answer should be very brief. 0.85. What is the ratio of the Aid received (constant 2012 US$) of Albania in 2007 to that in 2008?
Provide a short and direct response. 0.91. What is the ratio of the Aid received (constant 2012 US$) of Guatemala in 2007 to that in 2008?
Offer a terse response. 0.91. What is the ratio of the Aid received (constant 2012 US$) of High income in 2007 to that in 2009?
Offer a terse response. 0.92. What is the ratio of the Aid received (constant 2012 US$) in Albania in 2007 to that in 2009?
Make the answer very short. 0.9. What is the ratio of the Aid received (constant 2012 US$) in Guatemala in 2007 to that in 2009?
Provide a succinct answer. 1.23. What is the ratio of the Aid received (constant 2012 US$) in High income in 2007 to that in 2010?
Provide a short and direct response. 0.89. What is the ratio of the Aid received (constant 2012 US$) in Albania in 2007 to that in 2010?
Offer a terse response. 0.92. What is the ratio of the Aid received (constant 2012 US$) of Guatemala in 2007 to that in 2010?
Give a very brief answer. 1.16. What is the ratio of the Aid received (constant 2012 US$) of High income in 2007 to that in 2011?
Your answer should be compact. 2.06. What is the ratio of the Aid received (constant 2012 US$) in Albania in 2007 to that in 2011?
Provide a succinct answer. 0.95. What is the ratio of the Aid received (constant 2012 US$) of Guatemala in 2007 to that in 2011?
Keep it short and to the point. 1.24. What is the ratio of the Aid received (constant 2012 US$) of High income in 2007 to that in 2012?
Your answer should be very brief. 2.48. What is the ratio of the Aid received (constant 2012 US$) in Albania in 2007 to that in 2012?
Make the answer very short. 0.93. What is the ratio of the Aid received (constant 2012 US$) in Guatemala in 2007 to that in 2012?
Offer a very short reply. 1.56. What is the ratio of the Aid received (constant 2012 US$) in High income in 2007 to that in 2013?
Offer a very short reply. 3.01. What is the ratio of the Aid received (constant 2012 US$) in Albania in 2007 to that in 2013?
Your answer should be very brief. 1.1. What is the ratio of the Aid received (constant 2012 US$) in Guatemala in 2007 to that in 2013?
Offer a terse response. 0.96. What is the ratio of the Aid received (constant 2012 US$) in High income in 2008 to that in 2009?
Provide a short and direct response. 1.08. What is the ratio of the Aid received (constant 2012 US$) of Guatemala in 2008 to that in 2009?
Your response must be concise. 1.35. What is the ratio of the Aid received (constant 2012 US$) of High income in 2008 to that in 2010?
Offer a very short reply. 1.05. What is the ratio of the Aid received (constant 2012 US$) in Albania in 2008 to that in 2010?
Provide a short and direct response. 1.02. What is the ratio of the Aid received (constant 2012 US$) in Guatemala in 2008 to that in 2010?
Ensure brevity in your answer.  1.27. What is the ratio of the Aid received (constant 2012 US$) of High income in 2008 to that in 2011?
Ensure brevity in your answer.  2.42. What is the ratio of the Aid received (constant 2012 US$) of Albania in 2008 to that in 2011?
Your response must be concise. 1.05. What is the ratio of the Aid received (constant 2012 US$) in Guatemala in 2008 to that in 2011?
Your answer should be very brief. 1.36. What is the ratio of the Aid received (constant 2012 US$) of High income in 2008 to that in 2012?
Give a very brief answer. 2.92. What is the ratio of the Aid received (constant 2012 US$) in Albania in 2008 to that in 2012?
Give a very brief answer. 1.02. What is the ratio of the Aid received (constant 2012 US$) in Guatemala in 2008 to that in 2012?
Provide a succinct answer. 1.71. What is the ratio of the Aid received (constant 2012 US$) of High income in 2008 to that in 2013?
Your answer should be very brief. 3.53. What is the ratio of the Aid received (constant 2012 US$) of Albania in 2008 to that in 2013?
Provide a short and direct response. 1.21. What is the ratio of the Aid received (constant 2012 US$) in Guatemala in 2008 to that in 2013?
Your answer should be compact. 1.05. What is the ratio of the Aid received (constant 2012 US$) of High income in 2009 to that in 2010?
Your answer should be very brief. 0.97. What is the ratio of the Aid received (constant 2012 US$) in Albania in 2009 to that in 2010?
Provide a succinct answer. 1.02. What is the ratio of the Aid received (constant 2012 US$) of Guatemala in 2009 to that in 2010?
Provide a short and direct response. 0.94. What is the ratio of the Aid received (constant 2012 US$) of High income in 2009 to that in 2011?
Your answer should be very brief. 2.25. What is the ratio of the Aid received (constant 2012 US$) in Albania in 2009 to that in 2011?
Offer a very short reply. 1.06. What is the ratio of the Aid received (constant 2012 US$) of Guatemala in 2009 to that in 2011?
Your response must be concise. 1.01. What is the ratio of the Aid received (constant 2012 US$) in High income in 2009 to that in 2012?
Offer a terse response. 2.71. What is the ratio of the Aid received (constant 2012 US$) of Albania in 2009 to that in 2012?
Keep it short and to the point. 1.03. What is the ratio of the Aid received (constant 2012 US$) in Guatemala in 2009 to that in 2012?
Your answer should be very brief. 1.27. What is the ratio of the Aid received (constant 2012 US$) in High income in 2009 to that in 2013?
Your answer should be very brief. 3.28. What is the ratio of the Aid received (constant 2012 US$) of Albania in 2009 to that in 2013?
Make the answer very short. 1.22. What is the ratio of the Aid received (constant 2012 US$) in Guatemala in 2009 to that in 2013?
Ensure brevity in your answer.  0.78. What is the ratio of the Aid received (constant 2012 US$) of High income in 2010 to that in 2011?
Your answer should be very brief. 2.32. What is the ratio of the Aid received (constant 2012 US$) of Albania in 2010 to that in 2011?
Offer a very short reply. 1.04. What is the ratio of the Aid received (constant 2012 US$) in Guatemala in 2010 to that in 2011?
Keep it short and to the point. 1.07. What is the ratio of the Aid received (constant 2012 US$) in High income in 2010 to that in 2012?
Provide a succinct answer. 2.79. What is the ratio of the Aid received (constant 2012 US$) in Albania in 2010 to that in 2012?
Offer a terse response. 1.01. What is the ratio of the Aid received (constant 2012 US$) in Guatemala in 2010 to that in 2012?
Ensure brevity in your answer.  1.35. What is the ratio of the Aid received (constant 2012 US$) of High income in 2010 to that in 2013?
Provide a succinct answer. 3.38. What is the ratio of the Aid received (constant 2012 US$) of Albania in 2010 to that in 2013?
Offer a terse response. 1.19. What is the ratio of the Aid received (constant 2012 US$) in Guatemala in 2010 to that in 2013?
Make the answer very short. 0.82. What is the ratio of the Aid received (constant 2012 US$) of High income in 2011 to that in 2012?
Your response must be concise. 1.2. What is the ratio of the Aid received (constant 2012 US$) in Albania in 2011 to that in 2012?
Make the answer very short. 0.97. What is the ratio of the Aid received (constant 2012 US$) of Guatemala in 2011 to that in 2012?
Give a very brief answer. 1.26. What is the ratio of the Aid received (constant 2012 US$) in High income in 2011 to that in 2013?
Provide a succinct answer. 1.46. What is the ratio of the Aid received (constant 2012 US$) in Albania in 2011 to that in 2013?
Your response must be concise. 1.15. What is the ratio of the Aid received (constant 2012 US$) of Guatemala in 2011 to that in 2013?
Keep it short and to the point. 0.77. What is the ratio of the Aid received (constant 2012 US$) in High income in 2012 to that in 2013?
Make the answer very short. 1.21. What is the ratio of the Aid received (constant 2012 US$) of Albania in 2012 to that in 2013?
Your response must be concise. 1.18. What is the ratio of the Aid received (constant 2012 US$) of Guatemala in 2012 to that in 2013?
Your answer should be compact. 0.61. What is the difference between the highest and the second highest Aid received (constant 2012 US$) of High income?
Make the answer very short. 1.94e+07. What is the difference between the highest and the second highest Aid received (constant 2012 US$) of Albania?
Offer a very short reply. 1.40e+07. What is the difference between the highest and the second highest Aid received (constant 2012 US$) in Guatemala?
Your answer should be compact. 4.06e+07. What is the difference between the highest and the lowest Aid received (constant 2012 US$) in High income?
Give a very brief answer. 3.92e+08. What is the difference between the highest and the lowest Aid received (constant 2012 US$) of Albania?
Make the answer very short. 7.74e+07. What is the difference between the highest and the lowest Aid received (constant 2012 US$) in Guatemala?
Provide a succinct answer. 2.53e+08. 